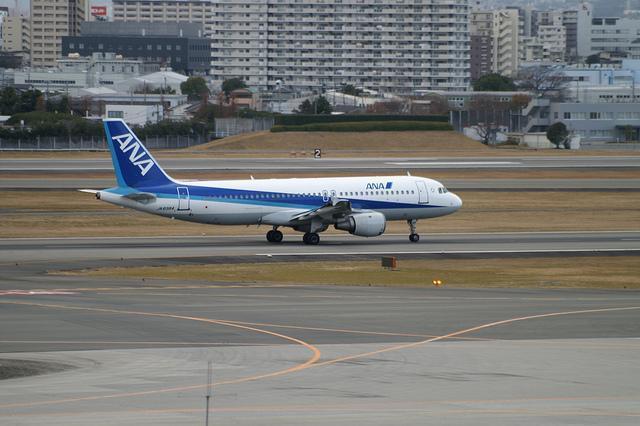How many houses can you count in the background behind the plane?
Give a very brief answer. 0. How many planes are there?
Give a very brief answer. 1. How many of the people are on a horse?
Give a very brief answer. 0. 